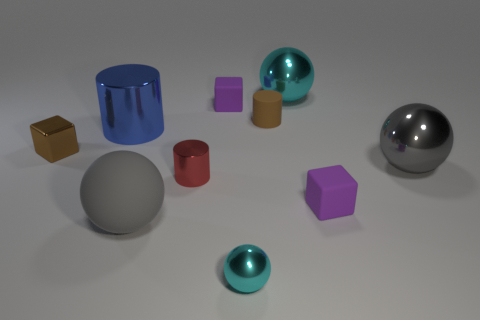Subtract all cylinders. How many objects are left? 7 Subtract 1 gray balls. How many objects are left? 9 Subtract all tiny blue matte balls. Subtract all tiny metallic objects. How many objects are left? 7 Add 1 purple matte objects. How many purple matte objects are left? 3 Add 1 small green metal balls. How many small green metal balls exist? 1 